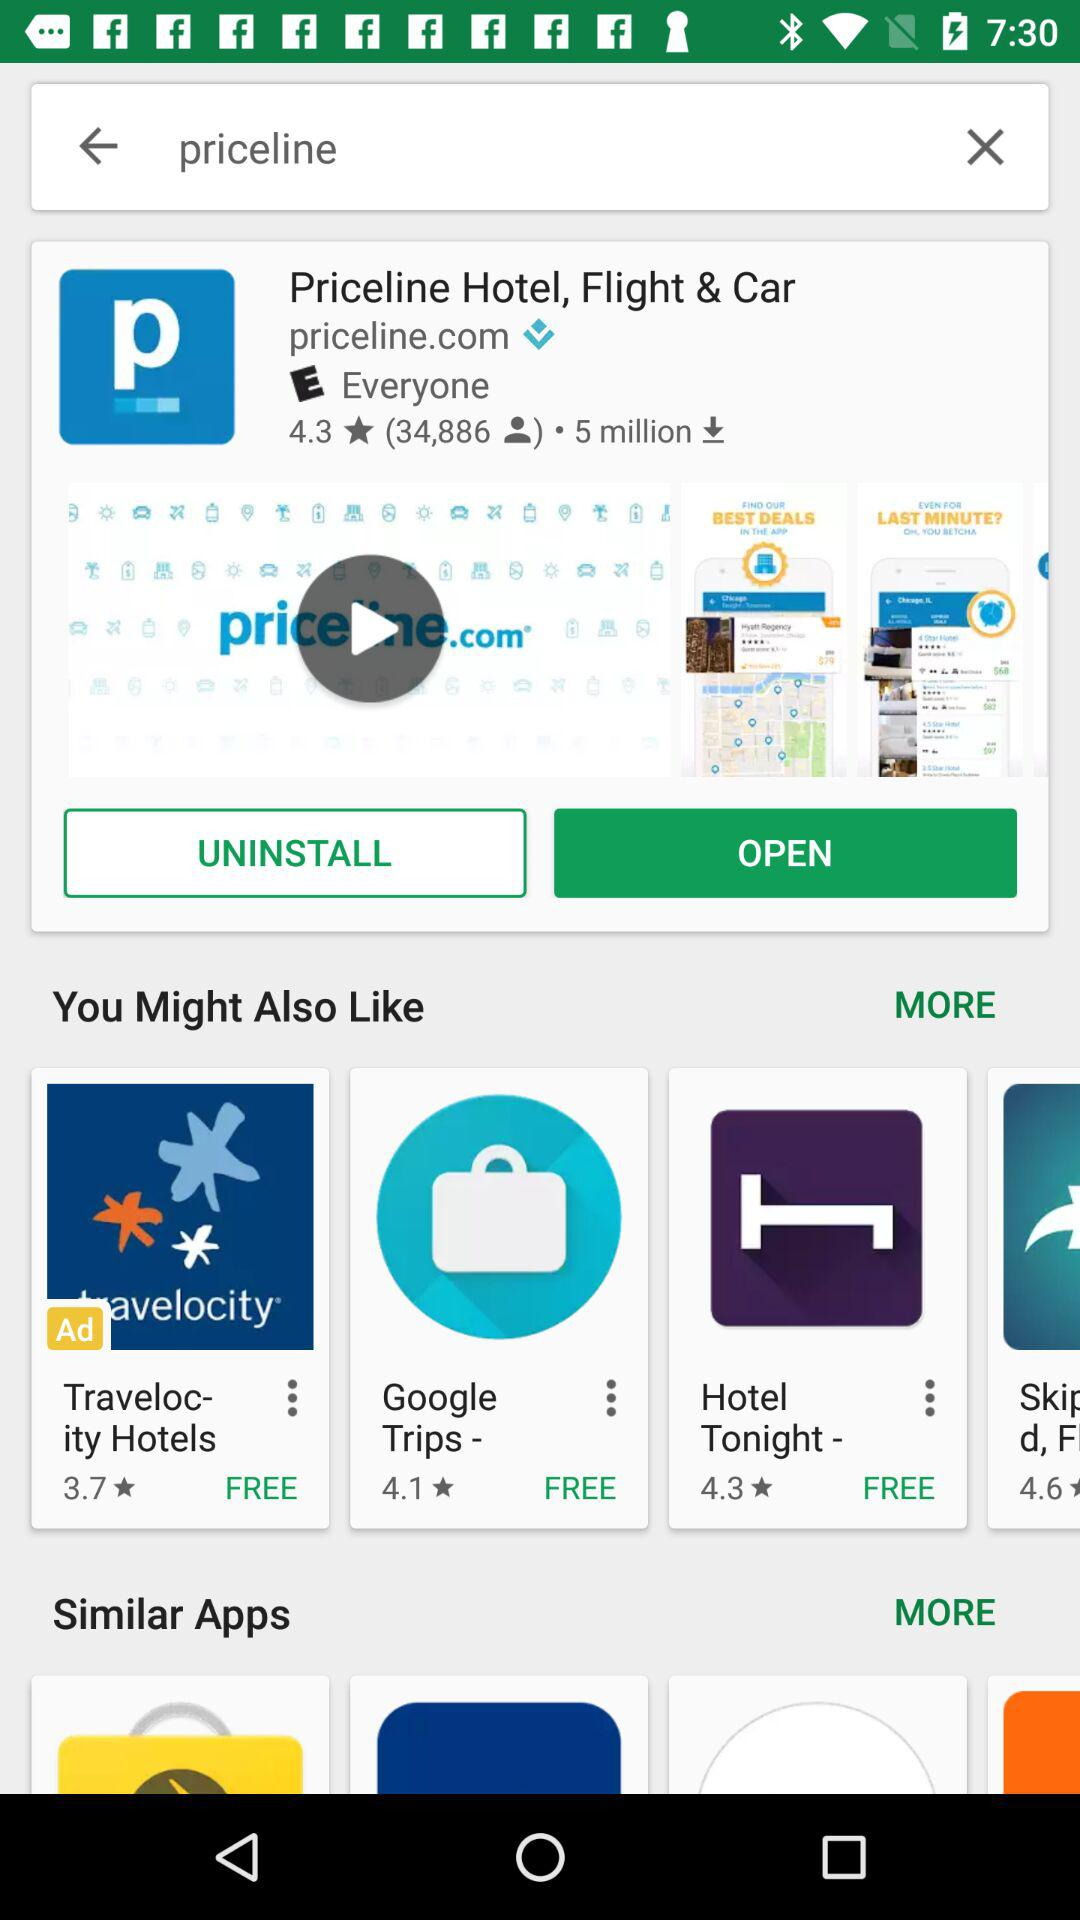How many people reviewed the application? The application is reviewed by 34,886 people. 